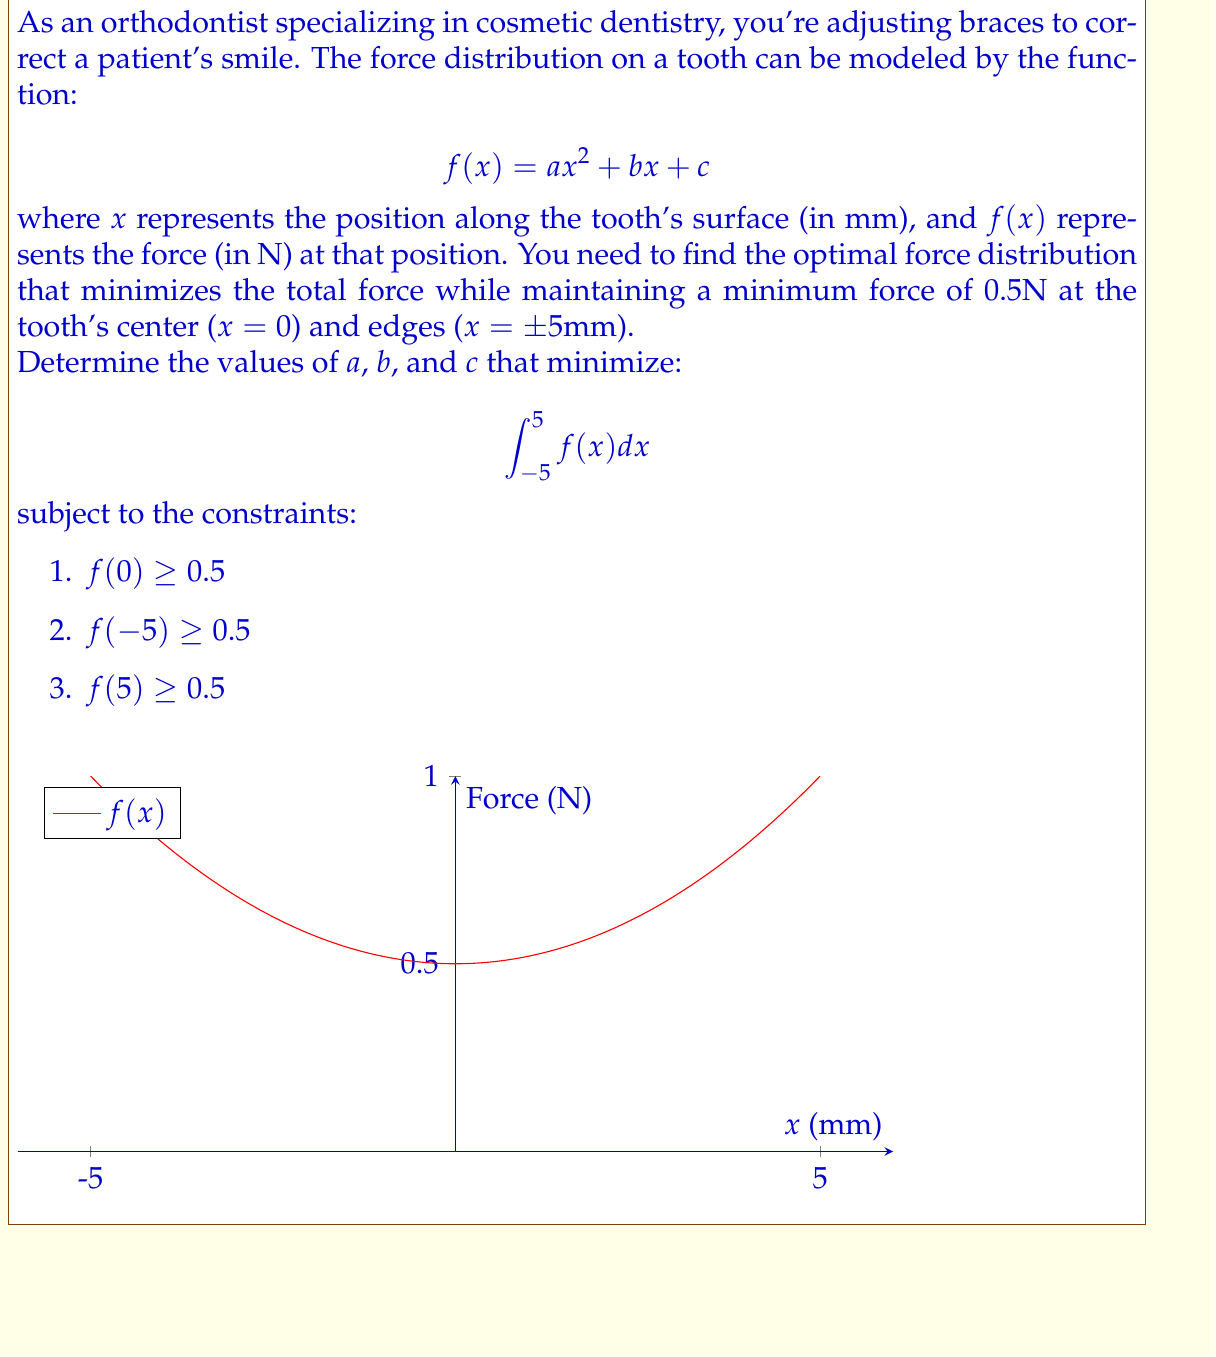Help me with this question. 1) First, we set up the optimization problem:
   Minimize: $$\int_{-5}^{5} (ax^2 + bx + c) dx$$
   Subject to: $a(0)^2 + b(0) + c \geq 0.5$
               $a(-5)^2 + b(-5) + c \geq 0.5$
               $a(5)^2 + b(5) + c \geq 0.5$

2) Simplify the constraints:
   $c \geq 0.5$
   $25a - 5b + c \geq 0.5$
   $25a + 5b + c \geq 0.5$

3) Evaluate the integral:
   $$\int_{-5}^{5} (ax^2 + bx + c) dx = \left[\frac{ax^3}{3} + \frac{bx^2}{2} + cx\right]_{-5}^{5}$$
   $$= \frac{a(125-(-125))}{3} + \frac{b(25-25)}{2} + c(5-(-5))$$
   $$= \frac{250a}{3} + 10c$$

4) Due to symmetry, the optimal solution will have $b = 0$.

5) The minimum force occurs at the boundaries, so the constraints become equalities:
   $c = 0.5$
   $25a + 0.5 = 0.5$

6) Solve for $a$:
   $25a = 0$
   $a = 0$

7) However, this violates the constraint at x = 0. The minimum possible $a$ that satisfies all constraints is:
   $25a + 0.5 = 0.5$
   $a = 0.02$

8) Therefore, the optimal function is:
   $f(x) = 0.02x^2 + 0.5$
Answer: $a = 0.02$, $b = 0$, $c = 0.5$ 